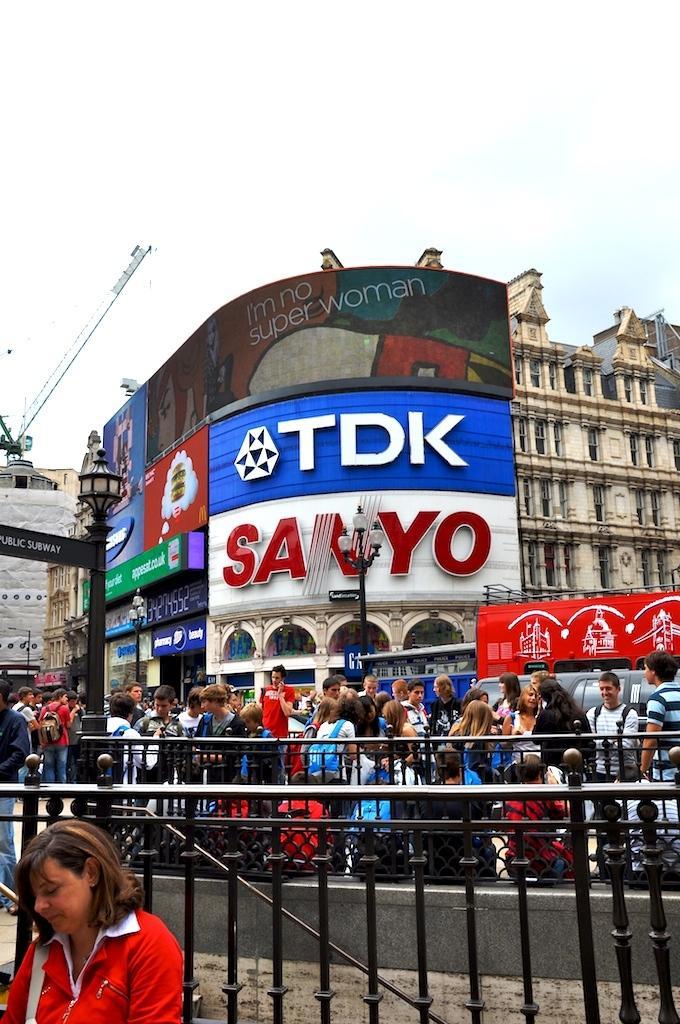Please provide a concise description of this image. In this image, on the left side, we can see a woman wearing a red color shirt. In the background, we can see a metal grill, buildings, window, hoardings, rotator. At the top, we can see a sky. 